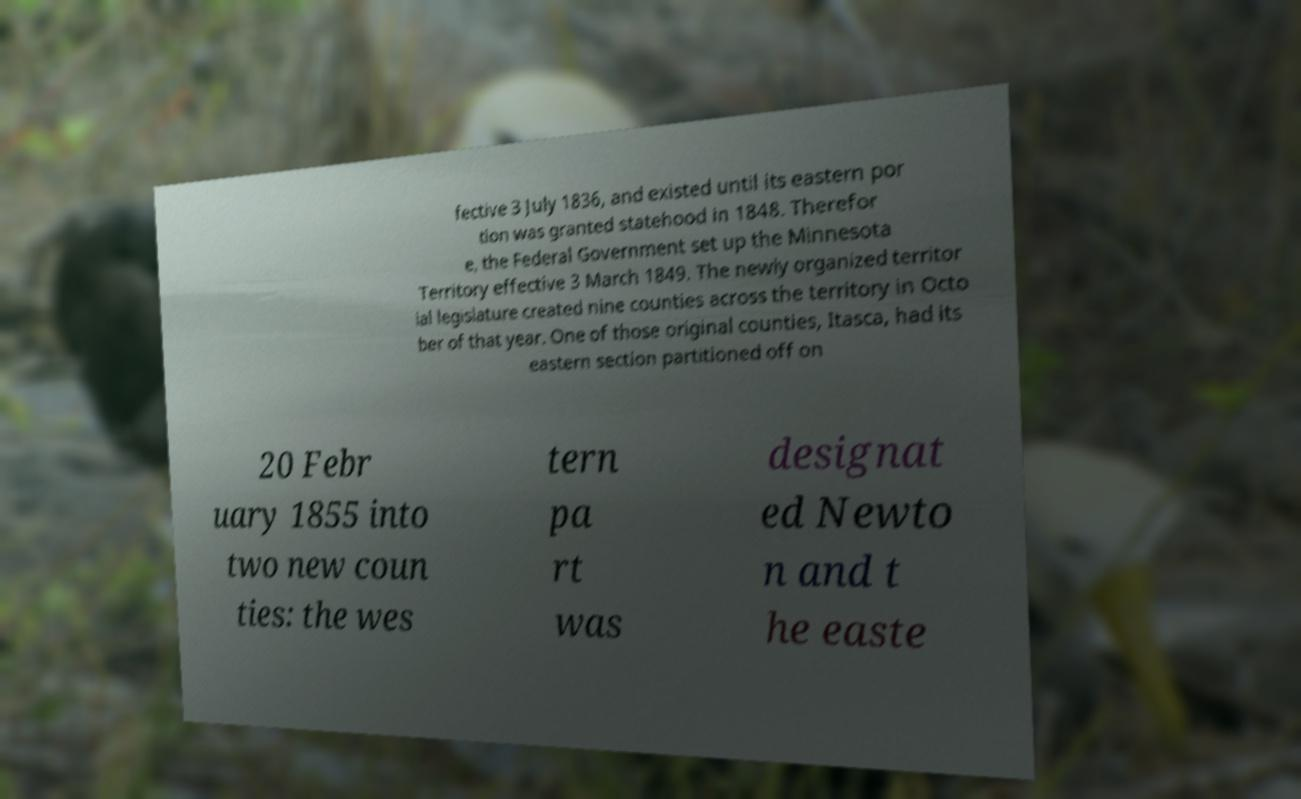Could you extract and type out the text from this image? fective 3 July 1836, and existed until its eastern por tion was granted statehood in 1848. Therefor e, the Federal Government set up the Minnesota Territory effective 3 March 1849. The newly organized territor ial legislature created nine counties across the territory in Octo ber of that year. One of those original counties, Itasca, had its eastern section partitioned off on 20 Febr uary 1855 into two new coun ties: the wes tern pa rt was designat ed Newto n and t he easte 